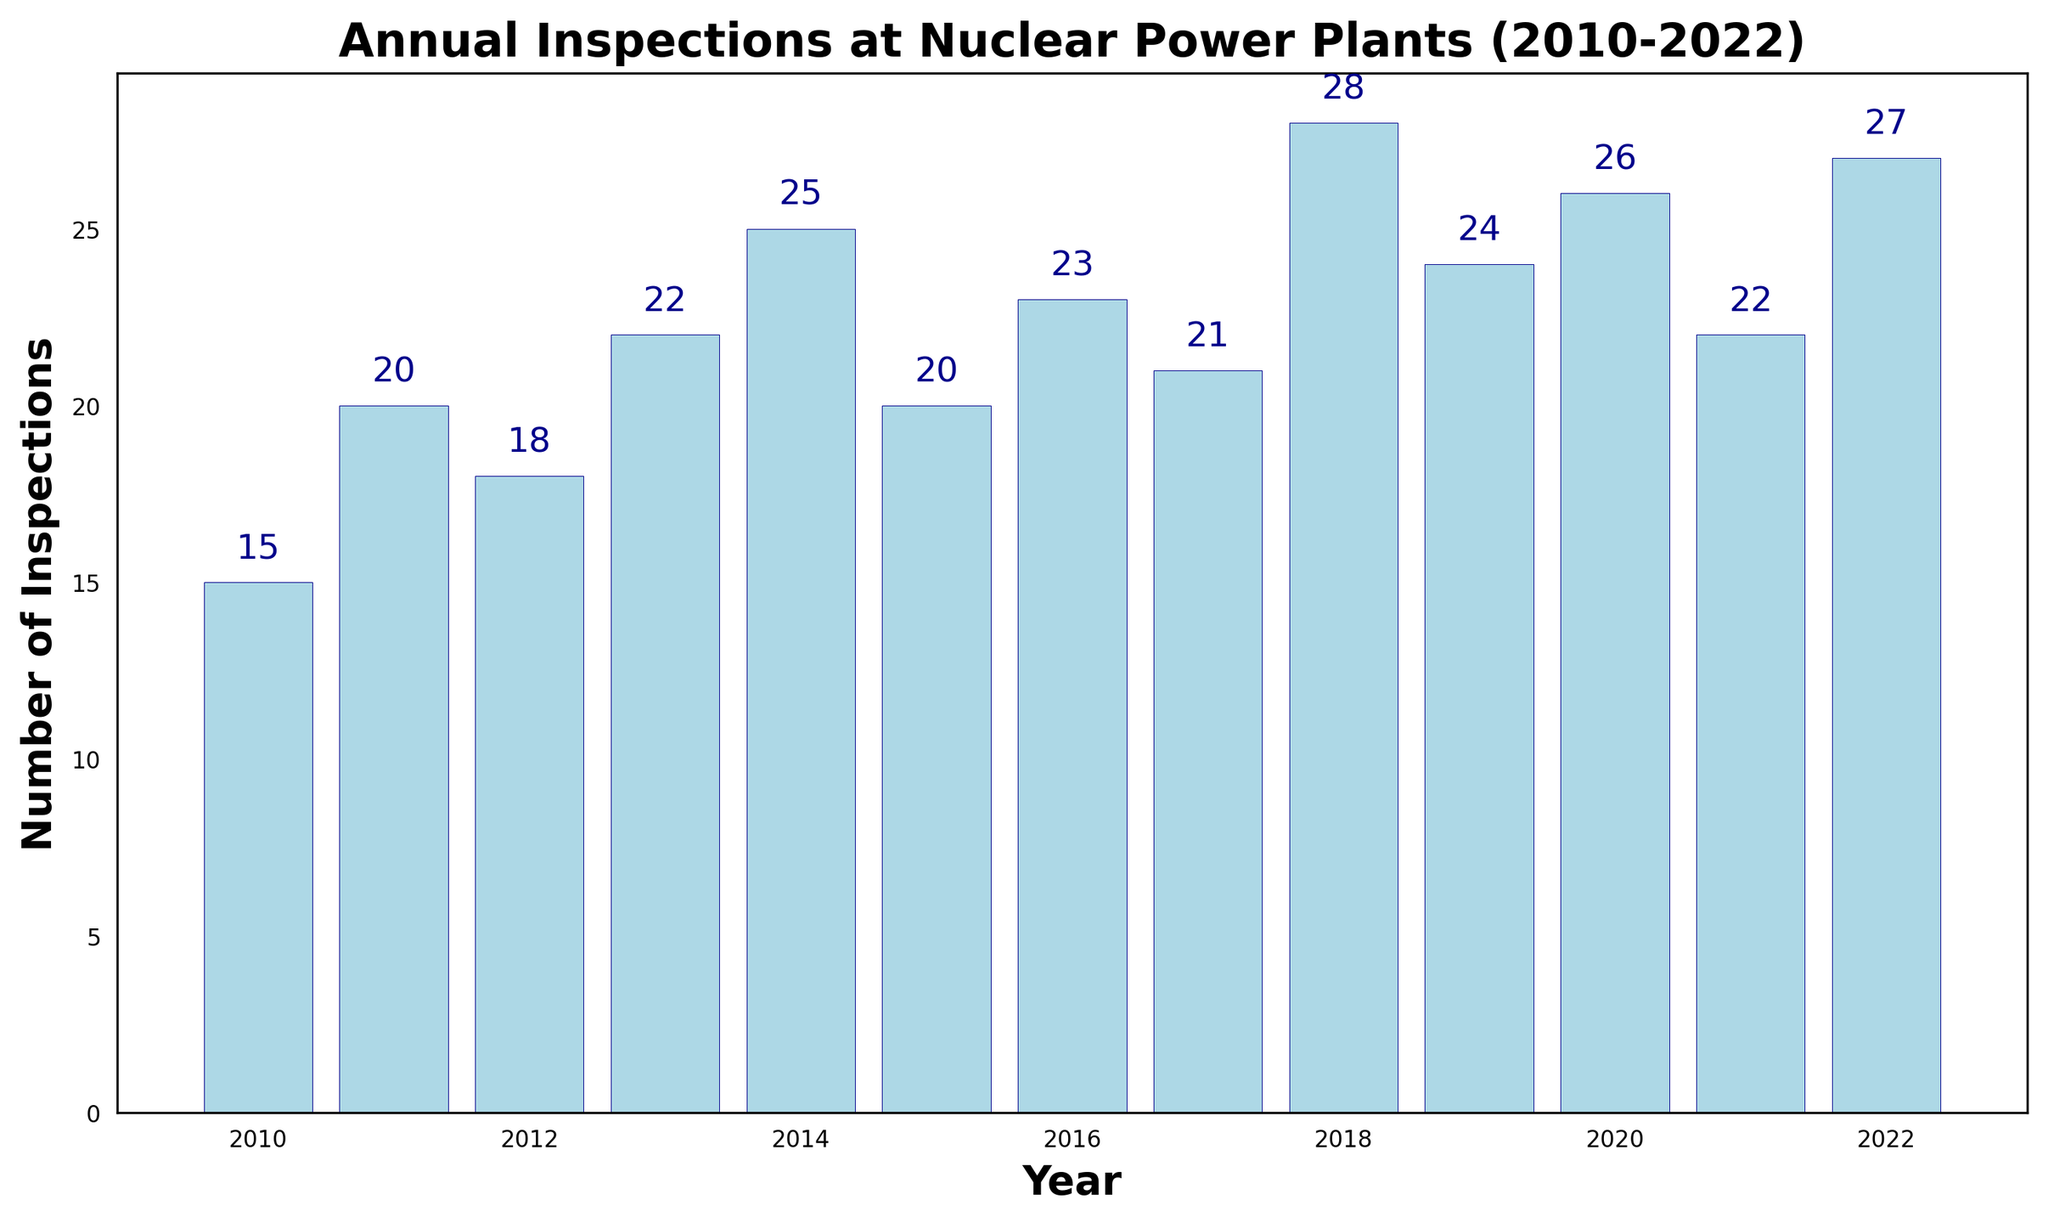What year had the highest number of inspections? To find the year with the highest number of inspections, look for the tallest bar in the bar chart. The number above this bar will indicate both the year and the number of inspections.
Answer: 2018 Which year had fewer inspections, 2015 or 2017? Compare the height of the bars for the years 2015 and 2017. The bar for 2017 is slightly taller than the bar for 2015, indicating more inspections.
Answer: 2015 What's the difference in the number of inspections between the year with the most and the least inspections? Identify the year with the highest number of inspections (2018 with 28 inspections) and the year with the lowest number of inspections (2010 with 15 inspections). Calculate the difference between these two values: 28 - 15.
Answer: 13 How many inspections were conducted in total from 2010 to 2012? Add the number of inspections for the years 2010, 2011, and 2012 by referring to the data above each bar: 15 (2010) + 20 (2011) + 18 (2012).
Answer: 53 Is the number of inspections in 2020 higher or lower than in 2019? Compare the heights of the bars for the years 2019 and 2020. The bar for 2020 is slightly taller than the bar for 2019.
Answer: Higher What is the average number of inspections per year over the entire period? Sum the number of inspections across all years and then divide by the total number of years. Sum: 15+20+18+22+25+20+23+21+28+24+26+22+27 = 291. Divide by the number of years (13): 291 / 13.
Answer: 22.38 (approximately 22.4) Between 2013 and 2016, which year saw the most significant increase in the number of inspections compared to the previous year? Compare the differences year to year: 
2014-2013: 25-22=3, 
2015-2014: 20-25=-5, 
2016-2015: 23-20=3. 
Both 2014 and 2016 saw the largest increase of 3 inspections each.
Answer: 2014 and 2016 What color are the bars used in the chart? Refer to the visual attributes of the bars in the chart, noting the fill and edge colors used. The bars are filled with light blue and have a dark blue edge.
Answer: Light blue (fill) and dark blue (edge) What is the total number of inspections conducted from 2018 to 2022? Add the number of inspections for the years 2018, 2019, 2020, 2021, and 2022: 28+24+26+22+27.
Answer: 127 Between which consecutive years is the variance in the number of inspections the smallest? Calculate the absolute difference between the number of inspections for each consecutive year and identify the smallest difference. The smallest variance (0) is between 2015 (20) and 2017 (21), and between 2013 (22) and 2021 (22).
Answer: 2013 and 2014 